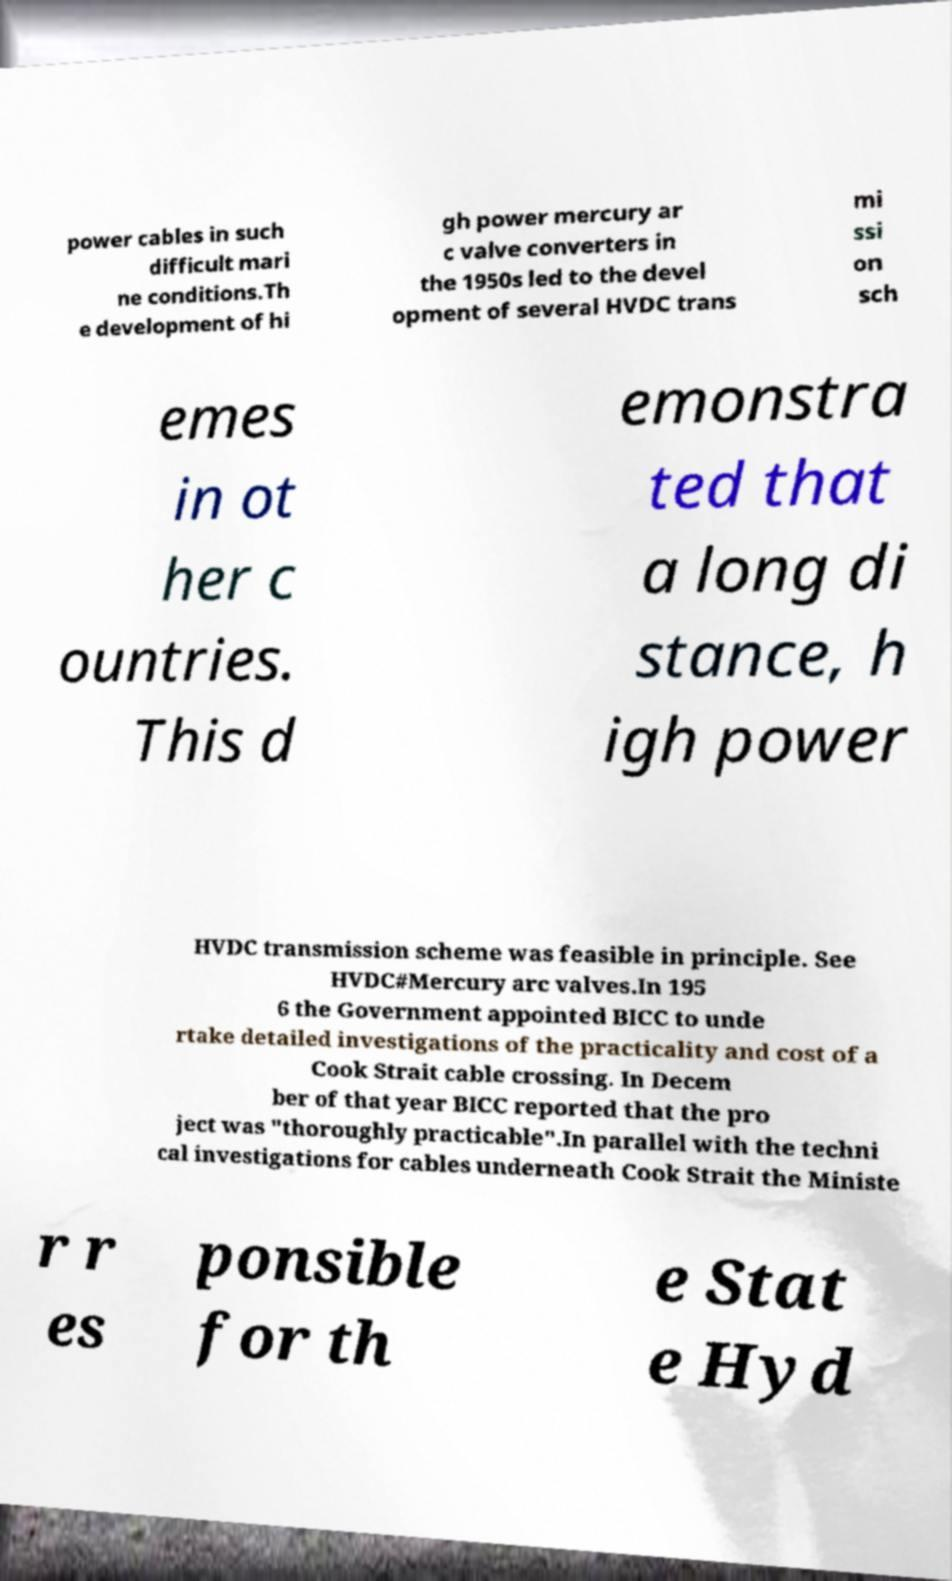Please read and relay the text visible in this image. What does it say? power cables in such difficult mari ne conditions.Th e development of hi gh power mercury ar c valve converters in the 1950s led to the devel opment of several HVDC trans mi ssi on sch emes in ot her c ountries. This d emonstra ted that a long di stance, h igh power HVDC transmission scheme was feasible in principle. See HVDC#Mercury arc valves.In 195 6 the Government appointed BICC to unde rtake detailed investigations of the practicality and cost of a Cook Strait cable crossing. In Decem ber of that year BICC reported that the pro ject was "thoroughly practicable".In parallel with the techni cal investigations for cables underneath Cook Strait the Ministe r r es ponsible for th e Stat e Hyd 